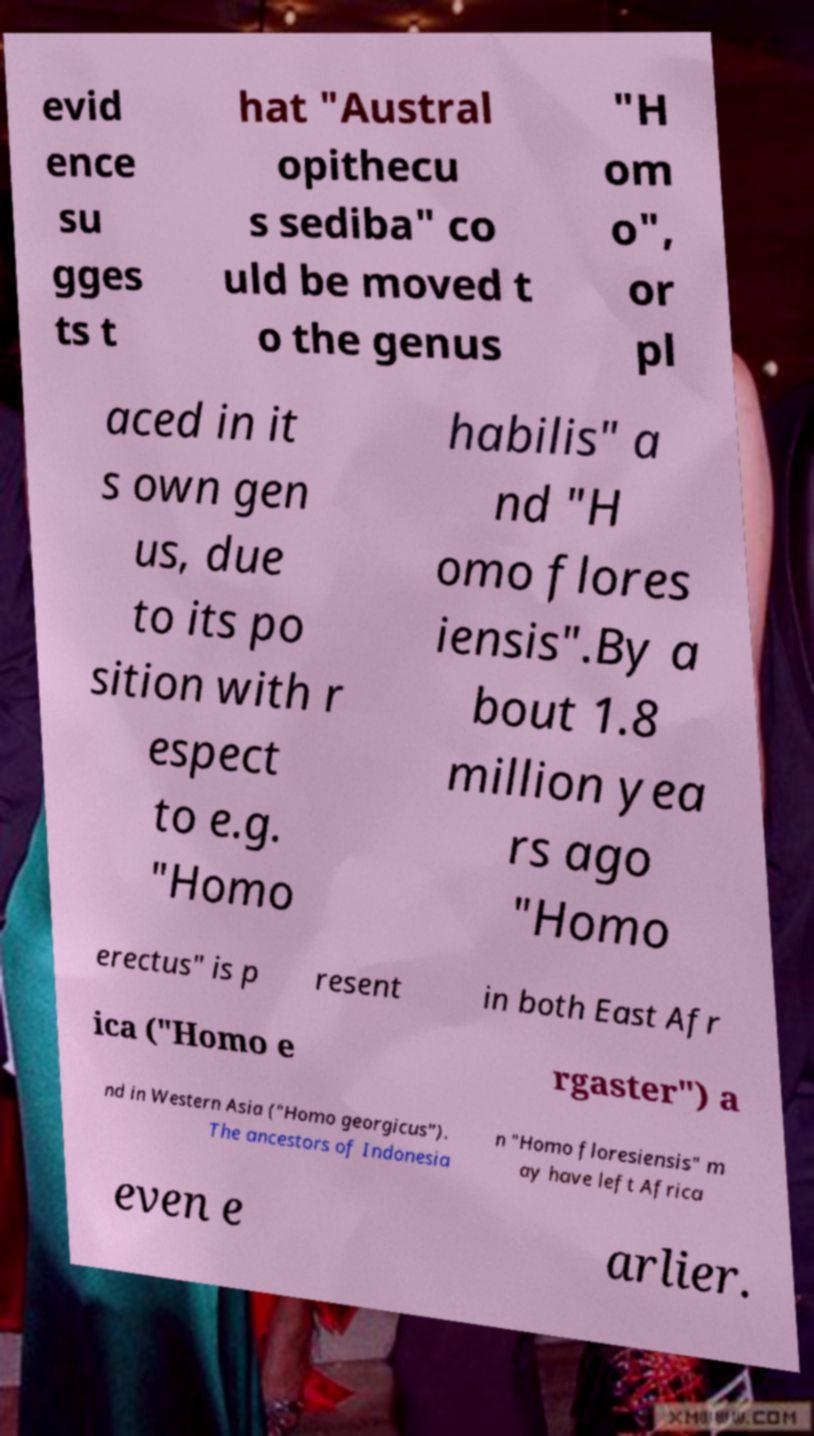I need the written content from this picture converted into text. Can you do that? evid ence su gges ts t hat "Austral opithecu s sediba" co uld be moved t o the genus "H om o", or pl aced in it s own gen us, due to its po sition with r espect to e.g. "Homo habilis" a nd "H omo flores iensis".By a bout 1.8 million yea rs ago "Homo erectus" is p resent in both East Afr ica ("Homo e rgaster") a nd in Western Asia ("Homo georgicus"). The ancestors of Indonesia n "Homo floresiensis" m ay have left Africa even e arlier. 